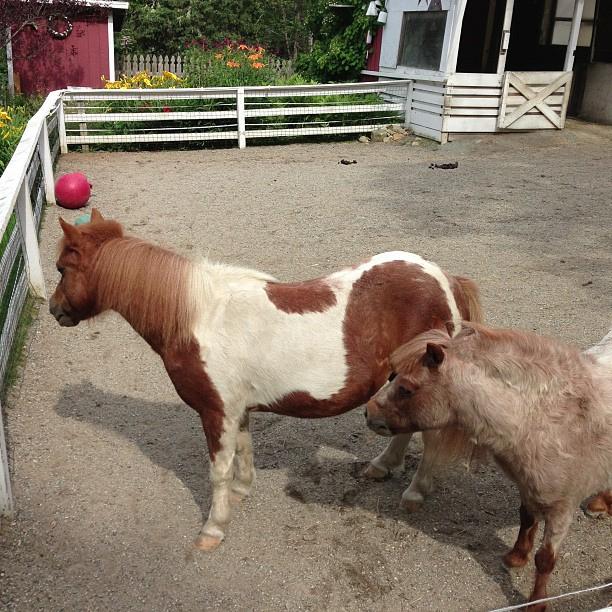What are the animals doing?
Short answer required. Standing. Is the animal standing?
Write a very short answer. Yes. What animals are these?
Be succinct. Horses. What color is the house?
Write a very short answer. Red. What color is the cow?
Write a very short answer. No cow. Is the horse wearing a saddle?
Concise answer only. No. Will this animals grow to be tall?
Be succinct. Yes. Is this a golden retriever?
Give a very brief answer. No. Are these domesticated animals?
Give a very brief answer. Yes. Is this picture in black & white or in color?
Be succinct. Color. 